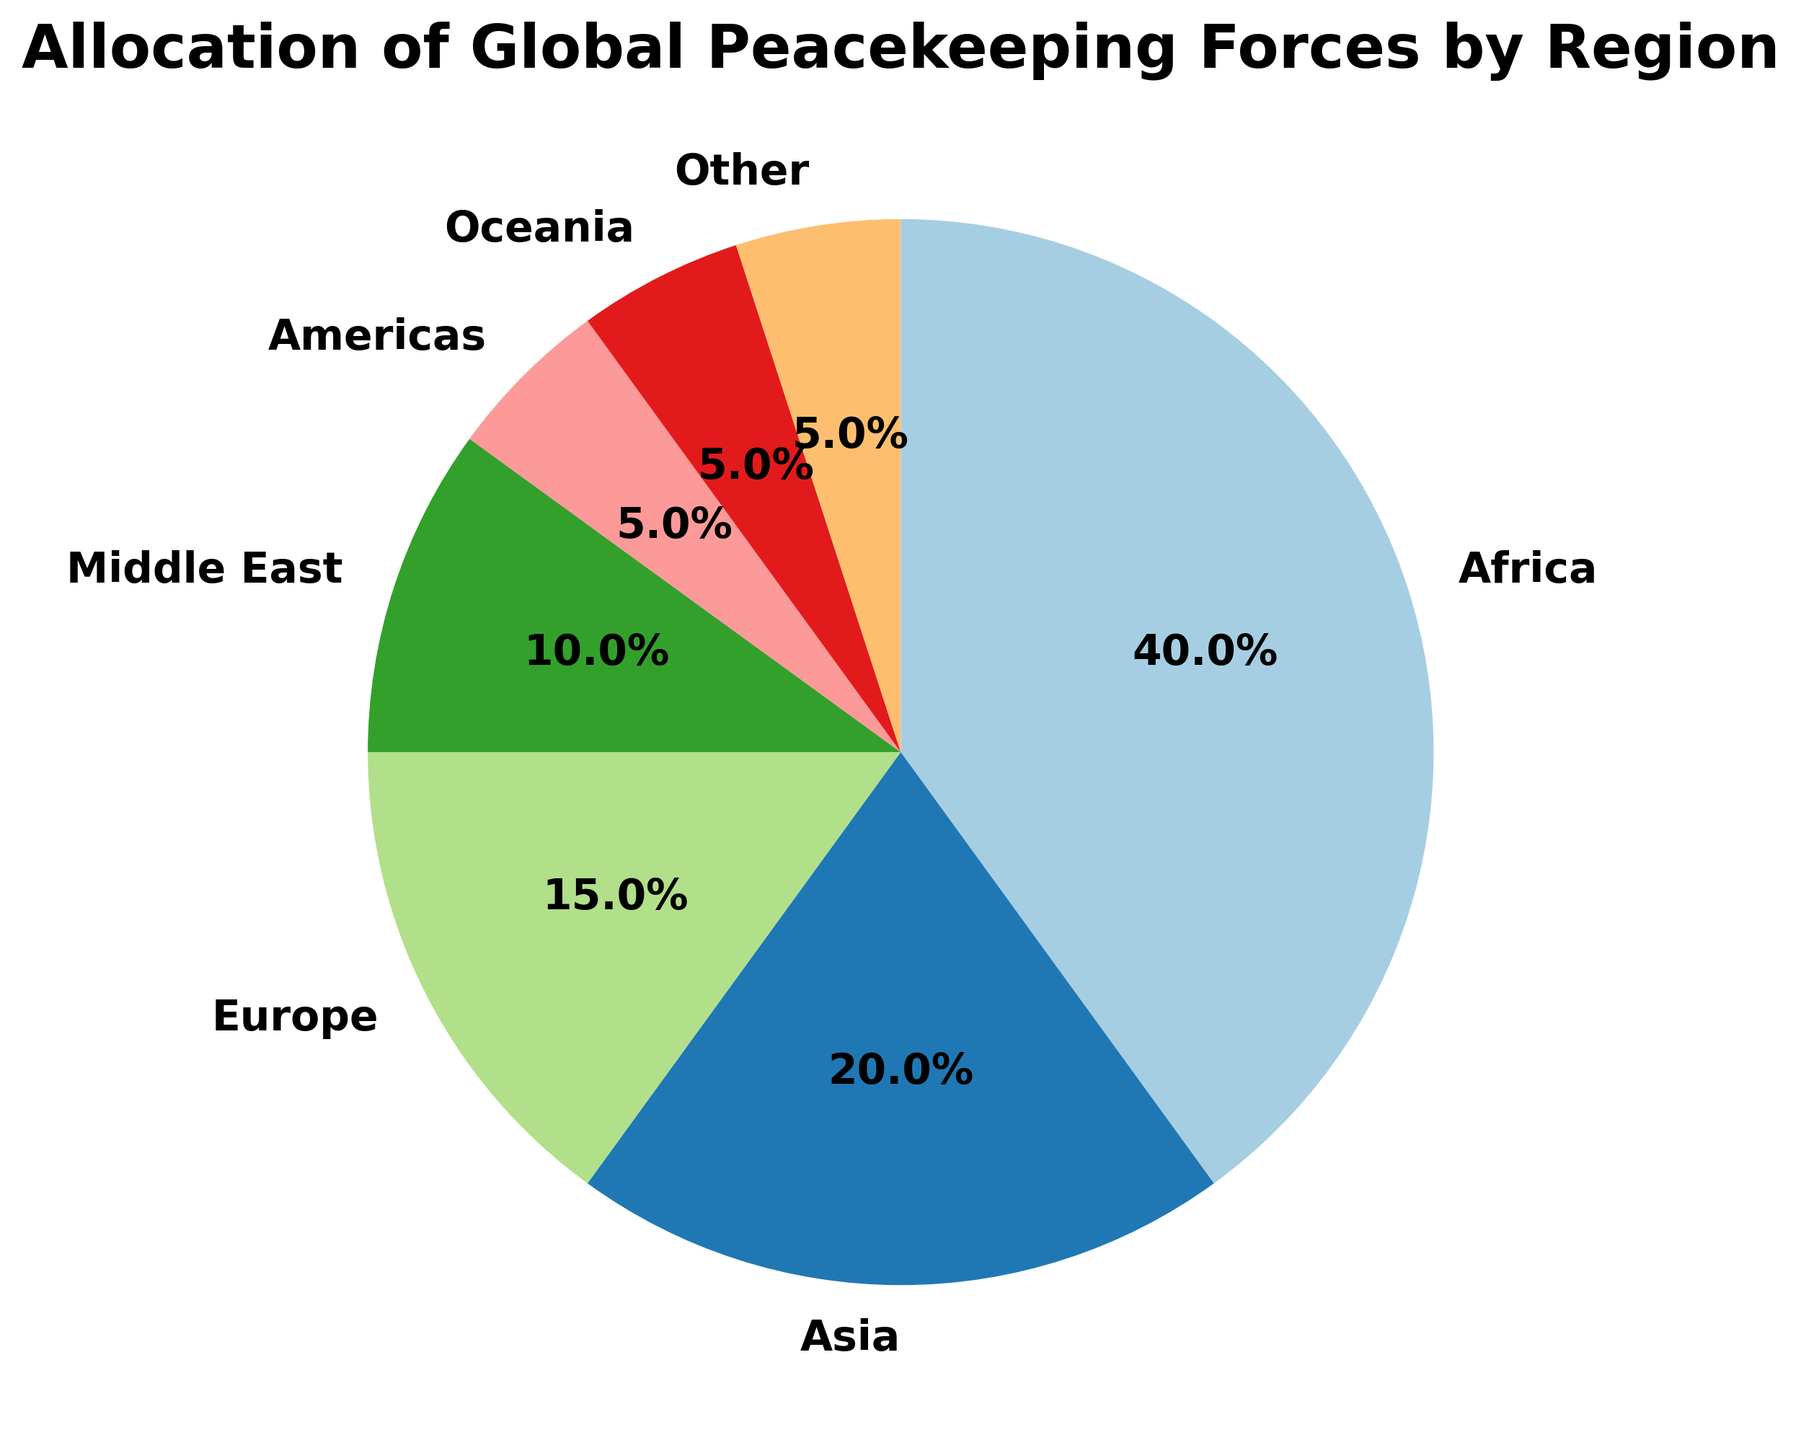What percentage of global peacekeeping forces is allocated to Africa and Asia combined? To find the combined allocation, add the percentages of Africa and Asia. Africa has 40% and Asia has 20%. So, 40% + 20% = 60%.
Answer: 60% Which region receives the smallest portion of global peacekeeping forces? By comparing the percentages, the Americas, Oceania, and "Other" each receive 5%. Since there is no other category with a smaller percentage, these three regions tie for the smallest portion.
Answer: Americas, Oceania, Other How does the allocation to Europe compare to that to the Middle East? Europe receives 15% of the peacekeeping forces, while the Middle East receives 10%. Therefore, Europe receives a larger allocation.
Answer: Europe receives more What is the difference between the allocations to Africa and the Middle East? To find the difference, subtract the percentage for the Middle East from that for Africa. Africa has 40% and the Middle East has 10%, so the difference is 40% - 10% = 30%.
Answer: 30% What fraction of the total peacekeeping forces is allocated to regions other than Africa? Combine the percentages of all regions other than Africa. Asia (20%) + Europe (15%) + Middle East (10%) + Americas (5%) + Oceania (5%) + Other (5%) = 60%. This is 60% of the total peacekeeping forces.
Answer: 60% Which regions together make up half of the total peacekeeping forces? We need to sum the largest percentages until we reach 50%. Africa (40%) + Asia (20%) = 60%. We notice that adding the third-largest portion (Europe) would exceed 50%. Therefore, the combination could be adjusted to: Africa (40%) + Europe (15%), which won't meet the exact 50% criteria. Hence, no exact combination meets exactly half based on given percentages.
Answer: None What is the average percentage allocation for all regions? To find the average, sum all the percentages and divide by the number of regions. (40% + 20% + 15% + 10% + 5% + 5% + 5%) / 7 = 100% / 7 ≈ 14.29%.
Answer: 14.29% If the allocation to the Americas and Oceania were combined into a single region, what would their percentage be? Add the percentages of the Americas and Oceania. Both regions have 5% each, so combined it's 5% + 5% = 10%.
Answer: 10% Which regions have an equal percentage of peacekeeping forces allocated? Looking at the data, Americas, Oceania, and "Other" each have 5% allocated.
Answer: Americas, Oceania, Other What percentage more forces does Africa receive than Europe? To find the percentage difference, subtract Europe's percentage from Africa's. Africa has 40%, Europe has 15%, so the difference is 40% - 15% = 25%.
Answer: 25% 